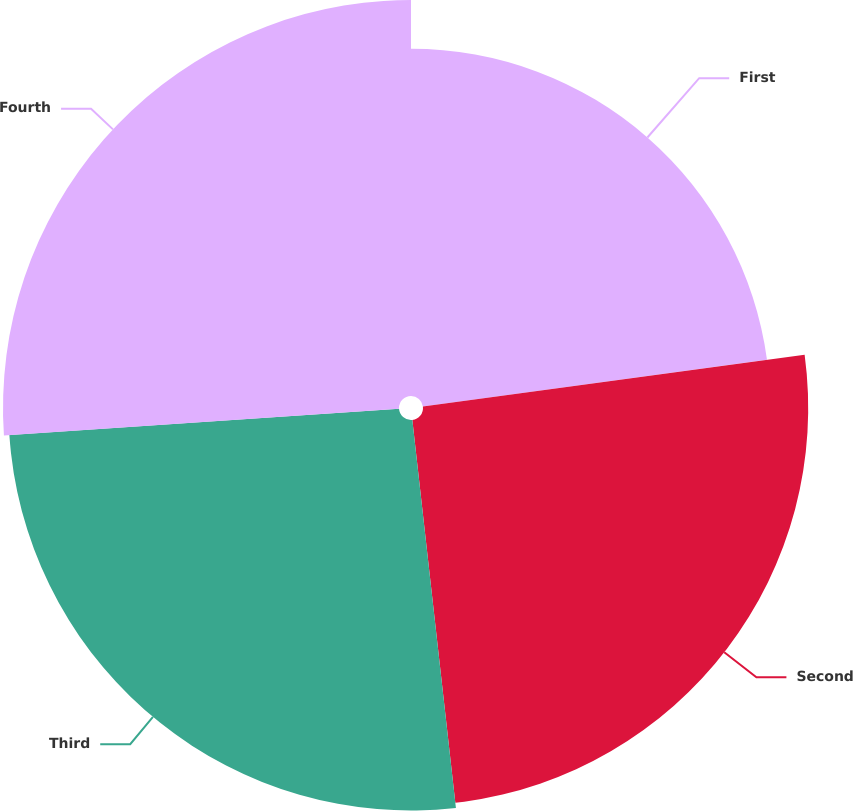Convert chart to OTSL. <chart><loc_0><loc_0><loc_500><loc_500><pie_chart><fcel>First<fcel>Second<fcel>Third<fcel>Fourth<nl><fcel>22.86%<fcel>25.36%<fcel>25.71%<fcel>26.07%<nl></chart> 